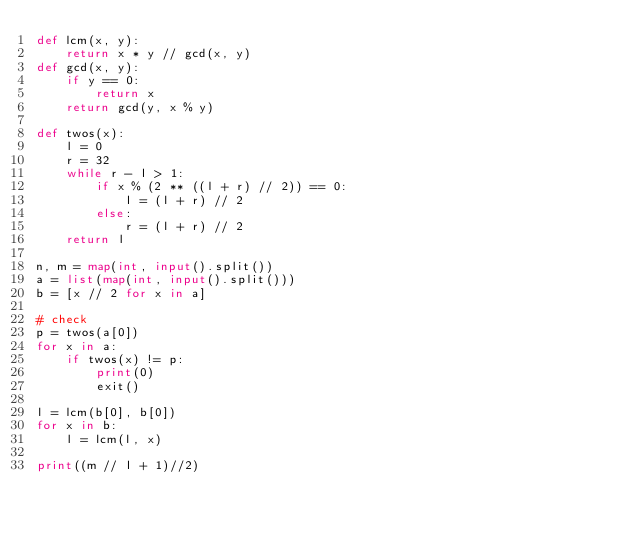Convert code to text. <code><loc_0><loc_0><loc_500><loc_500><_Python_>def lcm(x, y):
    return x * y // gcd(x, y)
def gcd(x, y):
    if y == 0:
        return x
    return gcd(y, x % y)

def twos(x):
    l = 0
    r = 32
    while r - l > 1:
        if x % (2 ** ((l + r) // 2)) == 0:
            l = (l + r) // 2
        else:
            r = (l + r) // 2
    return l

n, m = map(int, input().split())
a = list(map(int, input().split()))
b = [x // 2 for x in a]

# check
p = twos(a[0])
for x in a:
    if twos(x) != p:
        print(0)
        exit()

l = lcm(b[0], b[0])
for x in b:
    l = lcm(l, x)

print((m // l + 1)//2)</code> 